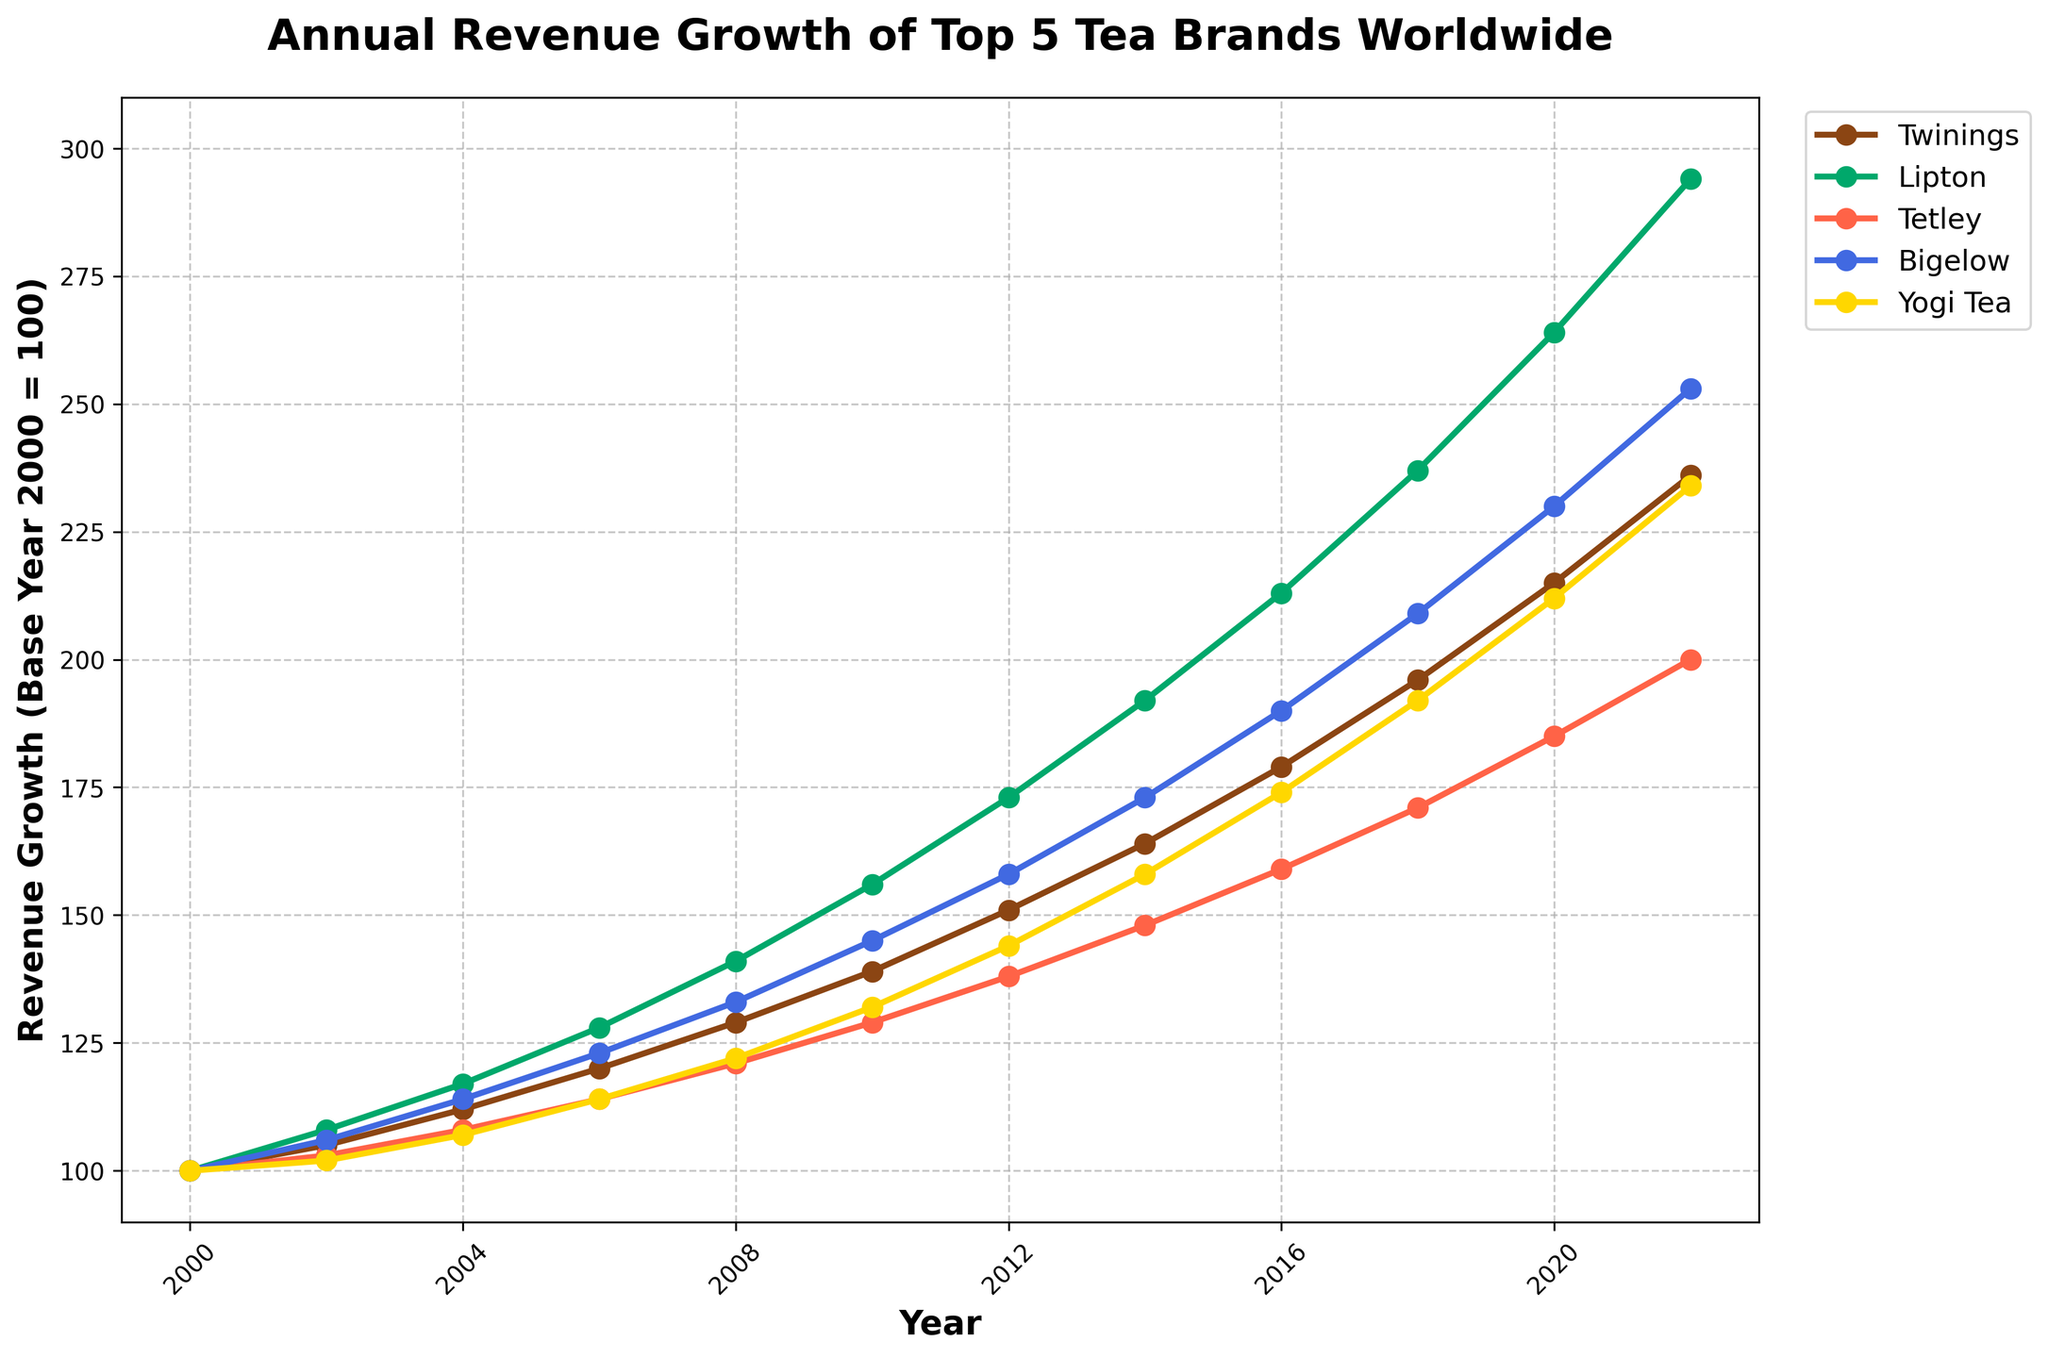Which tea brand had the highest revenue growth in 2022? By examining the endpoint of all lines on the graph for the year 2022, Lipton's line reaches the highest value compared to Twinings, Tetley, Bigelow, and Yogi Tea.
Answer: Lipton Between 2010 and 2014, which tea brand showed the greatest revenue growth? For each brand, look at the difference in their values from 2010 to 2014. Lipton grew from 156 to 192 (a growth of 36). Twinings grew from 139 to 164 (a growth of 25), Tetley grew from 129 to 148 (a growth of 19), Bigelow grew from 145 to 173 (a growth of 28), and Yogi Tea grew from 132 to 158 (a growth of 26). Lipton’s growth of 36 is the largest.
Answer: Lipton During which period did Yogi Tea experience the most significant growth? Identify the interval where the slope for Yogi Tea’s line (gold color) is steepest. From 2010 to 2014, Yogi Tea grew from 132 to 158. This represents a growth of 26, which is its most significant growth period.
Answer: 2010-2014 How did Tetley's revenue growth in 2008 compare to that of Twinings? Check the values for Twinings and Tetley in 2008. Twinings is at 129 and Tetley is at 121. Twinings' revenue was higher than Tetley's by 8 points.
Answer: Twinings' growth was higher by 8 Which brand maintained a consistent upward trend throughout the period? Observe the lines for all the brands. The lines for Twinings, Lipton, Tetley, Bigelow, and Yogi Tea all exhibit a consistent upward trend since 2000, with no declines.
Answer: All brands What was the approximate revenue growth for Bigelow in 2012? Locate the data point for Bigelow in 2012 on the chart. The value is marked as 158.
Answer: 158 Compare the revenue growth of Twinings and Bigelow in 2000 and 2022. In 2000, both started at 100. In 2022, Twinings is at 236 and Bigelow is at 253. Twinings' growth was 136 points, whereas Bigelow's growth was 153 points.
Answer: Bigelow grew more by 17 points Which tea brand had the least growth by 2006? Review each brand's value from 2000 to 2006. Twinings grew from 100 to 120 (20 points), Lipton from 100 to 128 (28 points), Tetley from 100 to 114 (14 points), Bigelow from 100 to 123 (23 points), and Yogi Tea from 100 to 114 (14 points). Tetley and Yogi Tea both had the least growth of 14 points.
Answer: Tetley and Yogi Tea 